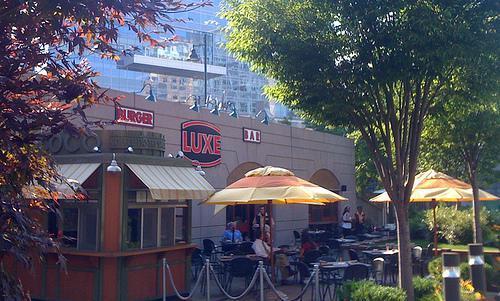How many lettered signs on the side of the building have a white background?
Give a very brief answer. 2. 